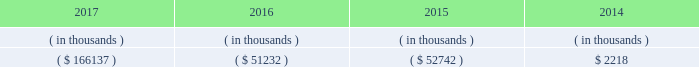Entergy arkansas 2019s receivables from or ( payables to ) the money pool were as follows as of december 31 for each of the following years. .
See note 4 to the financial statements for a description of the money pool .
Entergy arkansas has a credit facility in the amount of $ 150 million scheduled to expire in august 2022 .
Entergy arkansas also has a $ 20 million credit facility scheduled to expire in april 2018 . a0 a0the $ 150 million credit facility permits the issuance of letters of credit against $ 5 million of the borrowing capacity of the facility .
As of december 31 , 2017 , there were no cash borrowings and no letters of credit outstanding under the credit facilities .
In addition , entergy arkansas is a party to an uncommitted letter of credit facility as a means to post collateral to support its obligations to miso .
As of december 31 , 2017 , a $ 1 million letter of credit was outstanding under entergy arkansas 2019s uncommitted letter of credit facility .
See note 4 to the financial statements for further discussion of the credit facilities .
The entergy arkansas nuclear fuel company variable interest entity has a credit facility in the amount of $ 80 million scheduled to expire in may 2019 . a0 a0as of december 31 , 2017 , $ 50 million in letters of credit to support a like amount of commercial paper issued and $ 24.9 million in loans were outstanding under the entergy arkansas nuclear fuel company variable interest entity credit facility .
See note 4 to the financial statements for further discussion of the nuclear fuel company variable interest entity credit facility .
Entergy arkansas obtained authorizations from the ferc through october 2019 for short-term borrowings not to exceed an aggregate amount of $ 250 million at any time outstanding and borrowings by its nuclear fuel company variable interest entity .
See note 4 to the financial statements for further discussion of entergy arkansas 2019s short-term borrowing limits .
The long-term securities issuances of entergy arkansas are limited to amounts authorized by the apsc , and the current authorization extends through december 2018 .
Entergy arkansas , inc .
And subsidiaries management 2019s financial discussion and analysis state and local rate regulation and fuel-cost recovery retail rates 2015 base rate filing in april 2015 , entergy arkansas filed with the apsc for a general change in rates , charges , and tariffs .
The filing notified the apsc of entergy arkansas 2019s intent to implement a forward test year formula rate plan pursuant to arkansas legislation passed in 2015 , and requested a retail rate increase of $ 268.4 million , with a net increase in revenue of $ 167 million .
The filing requested a 10.2% ( 10.2 % ) return on common equity .
In september 2015 the apsc staff and intervenors filed direct testimony , with the apsc staff recommending a revenue requirement of $ 217.9 million and a 9.65% ( 9.65 % ) return on common equity .
In december 2015 , entergy arkansas , the apsc staff , and certain of the intervenors in the rate case filed with the apsc a joint motion for approval of a settlement of the case that proposed a retail rate increase of approximately $ 225 million with a net increase in revenue of approximately $ 133 million ; an authorized return on common equity of 9.75% ( 9.75 % ) ; and a formula rate plan tariff that provides a +/- 50 basis point band around the 9.75% ( 9.75 % ) allowed return on common equity .
A significant portion of the rate increase is related to entergy arkansas 2019s acquisition in march 2016 of union power station power block 2 for a base purchase price of $ 237 million .
The settlement agreement also provided for amortization over a 10-year period of $ 7.7 million of previously-incurred costs related to ano post-fukushima compliance and $ 9.9 million of previously-incurred costs related to ano flood barrier compliance .
A settlement hearing was held in january 2016 .
In february 2016 the apsc approved the settlement with one exception that reduced the retail rate increase proposed in the settlement by $ 5 million .
The settling parties agreed to the apsc modifications in february 2016 .
The new rates were effective february 24 , 2016 and began billing with the first billing cycle of april 2016 .
In march 2016 , entergy arkansas made a compliance filing regarding the .
In 2016 as part of the entergy arkansas 2019s intent to implement a forward test year formula rate plan pursuant to arkansas legislation passed in 2015 , what was the ratio of the and requested a retail rate increase to the net increase? 
Computations: (268.4 / 167)
Answer: 1.60719. 